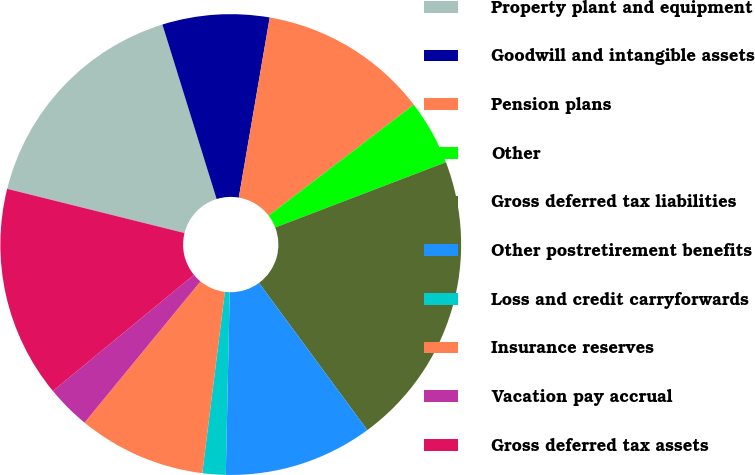Convert chart to OTSL. <chart><loc_0><loc_0><loc_500><loc_500><pie_chart><fcel>Property plant and equipment<fcel>Goodwill and intangible assets<fcel>Pension plans<fcel>Other<fcel>Gross deferred tax liabilities<fcel>Other postretirement benefits<fcel>Loss and credit carryforwards<fcel>Insurance reserves<fcel>Vacation pay accrual<fcel>Gross deferred tax assets<nl><fcel>16.32%<fcel>7.5%<fcel>11.91%<fcel>4.57%<fcel>20.72%<fcel>10.44%<fcel>1.63%<fcel>8.97%<fcel>3.1%<fcel>14.85%<nl></chart> 